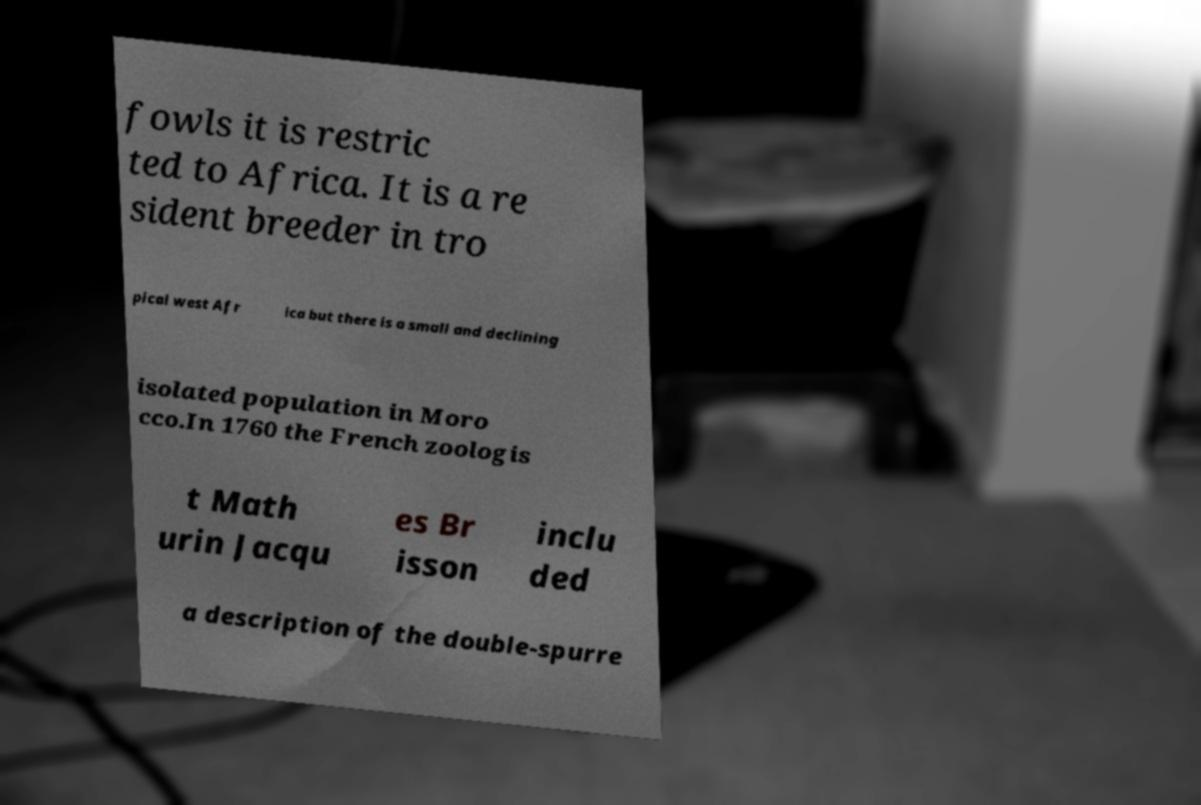Please identify and transcribe the text found in this image. fowls it is restric ted to Africa. It is a re sident breeder in tro pical west Afr ica but there is a small and declining isolated population in Moro cco.In 1760 the French zoologis t Math urin Jacqu es Br isson inclu ded a description of the double-spurre 